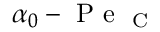Convert formula to latex. <formula><loc_0><loc_0><loc_500><loc_500>\alpha _ { 0 } - P e _ { C }</formula> 